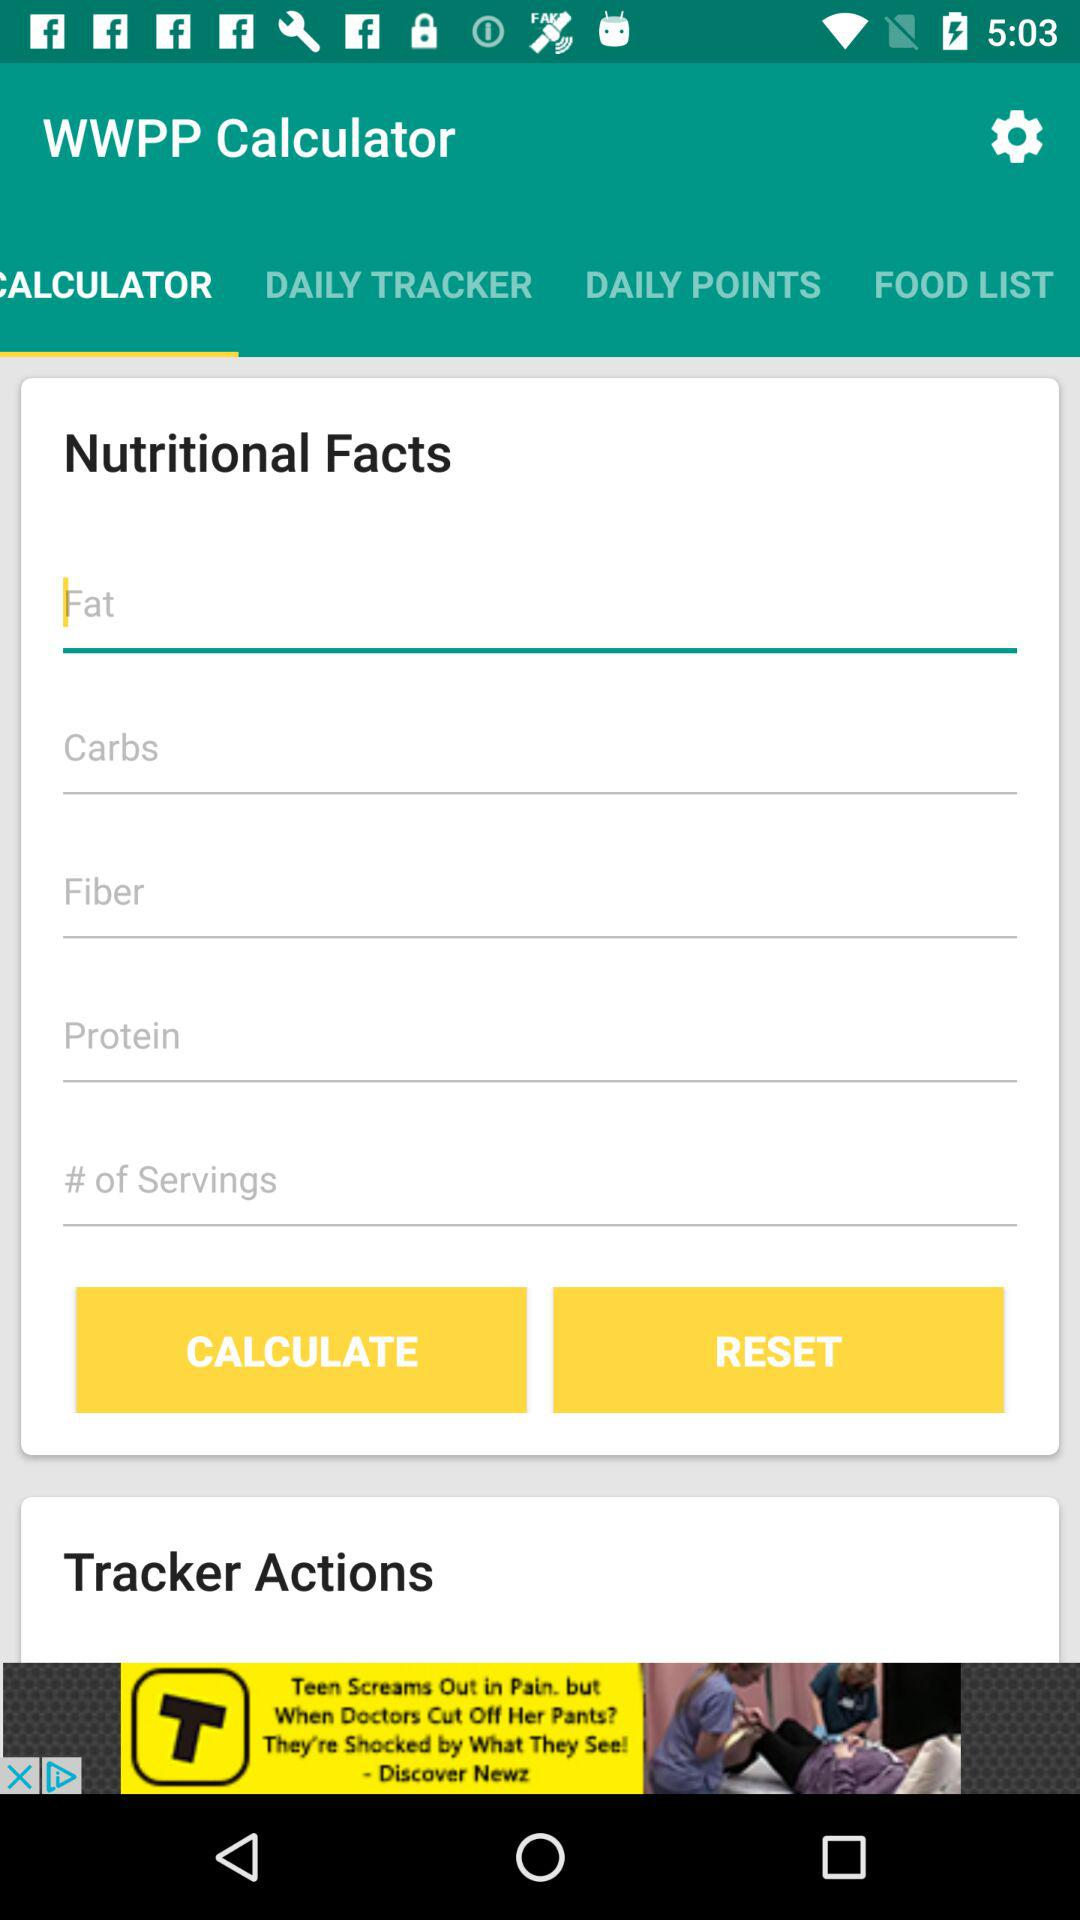Which tab is selected?
When the provided information is insufficient, respond with <no answer>. <no answer> 